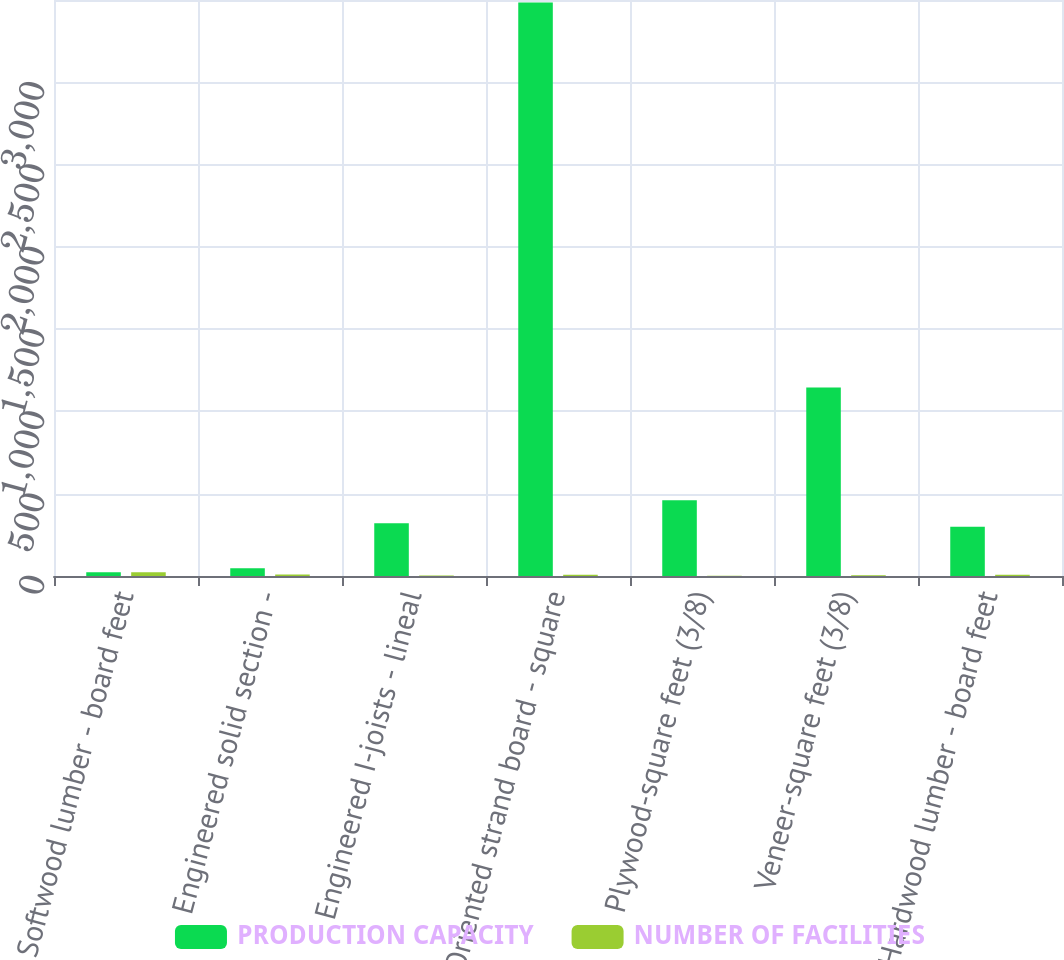<chart> <loc_0><loc_0><loc_500><loc_500><stacked_bar_chart><ecel><fcel>Softwood lumber - board feet<fcel>Engineered solid section -<fcel>Engineered I-joists - lineal<fcel>Oriented strand board - square<fcel>Plywood-square feet (3/8)<fcel>Veneer-square feet (3/8)<fcel>Hardwood lumber - board feet<nl><fcel>PRODUCTION CAPACITY<fcel>23<fcel>47<fcel>320<fcel>3485<fcel>460<fcel>1145<fcel>300<nl><fcel>NUMBER OF FACILITIES<fcel>23<fcel>9<fcel>3<fcel>7<fcel>2<fcel>5<fcel>7<nl></chart> 